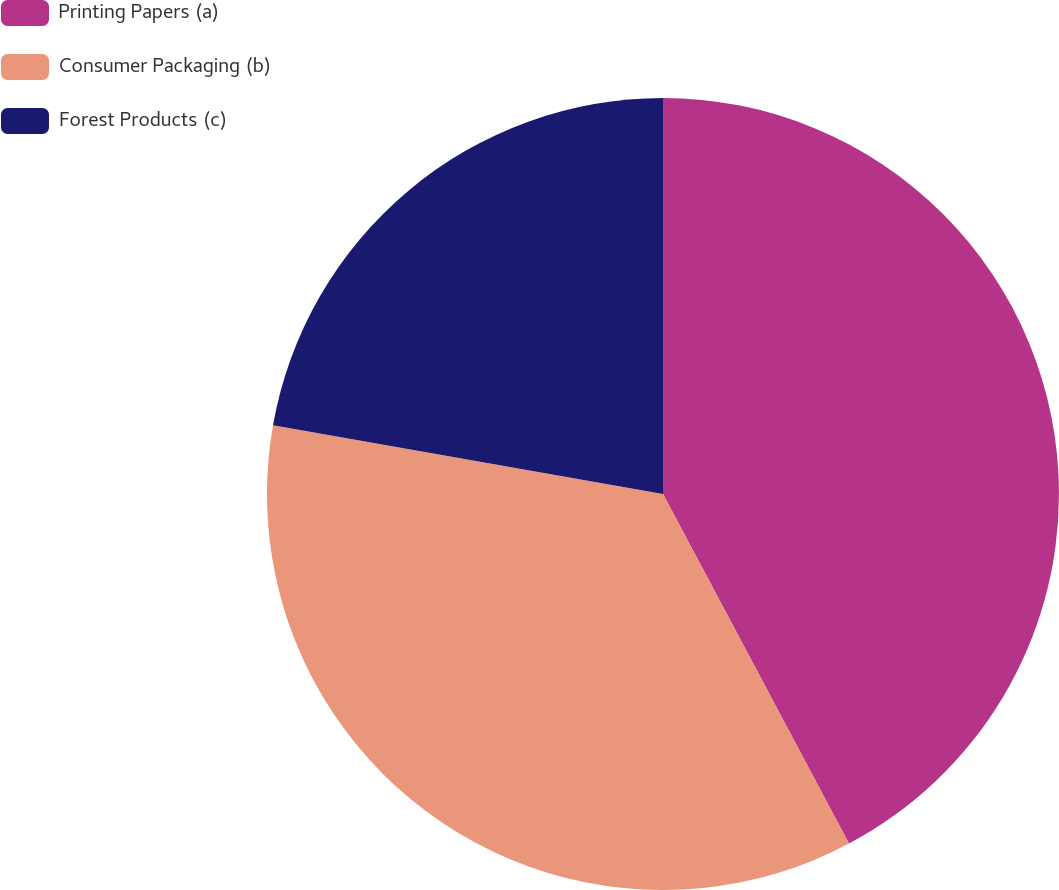Convert chart to OTSL. <chart><loc_0><loc_0><loc_500><loc_500><pie_chart><fcel>Printing Papers (a)<fcel>Consumer Packaging (b)<fcel>Forest Products (c)<nl><fcel>42.22%<fcel>35.56%<fcel>22.22%<nl></chart> 